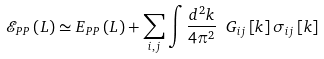Convert formula to latex. <formula><loc_0><loc_0><loc_500><loc_500>\mathcal { E } _ { P P } \left ( L \right ) \simeq E _ { P P } \left ( L \right ) + \sum _ { i , j } \int \frac { d ^ { 2 } k } { 4 \pi ^ { 2 } } \ G _ { i j } \left [ k \right ] \sigma _ { i j } \left [ k \right ]</formula> 